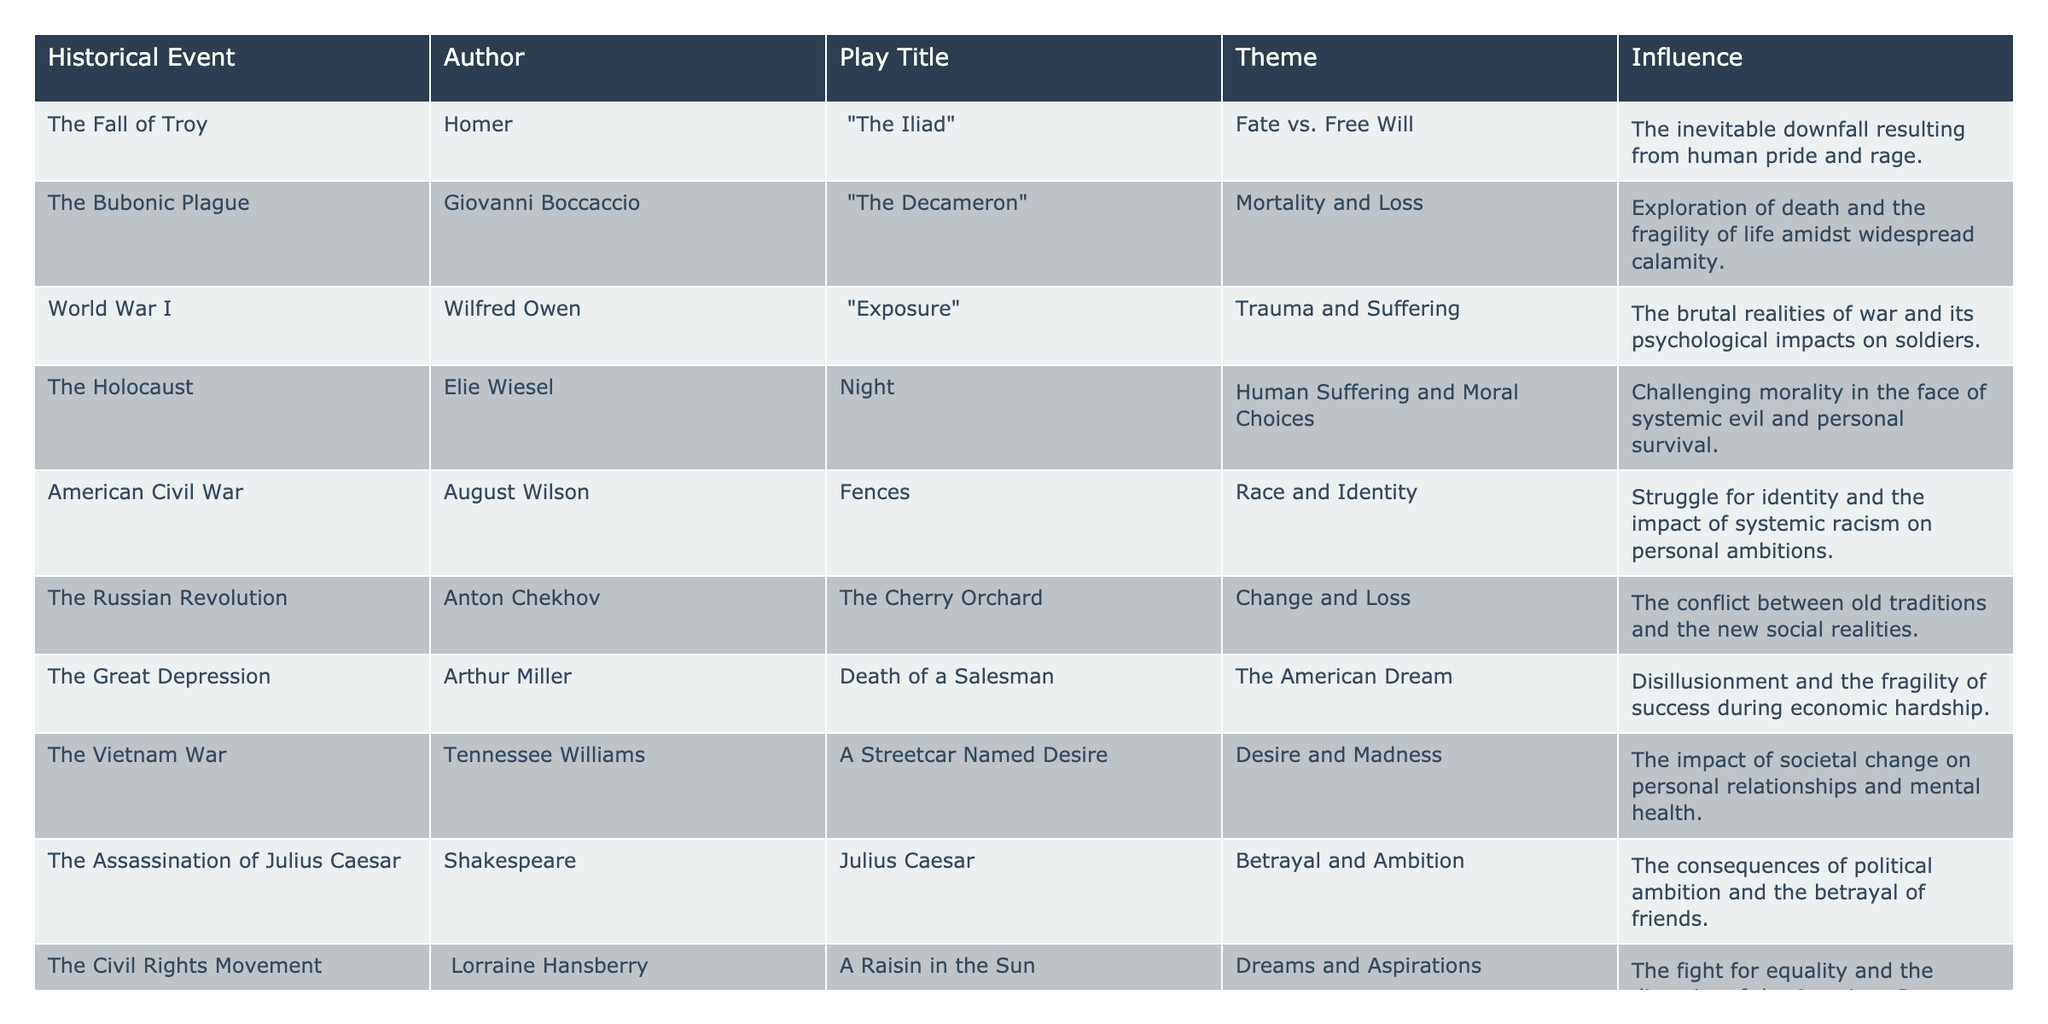What is the theme of "Death of a Salesman"? Referring to the table, under the play title "Death of a Salesman," the theme listed is "The American Dream."
Answer: The American Dream Which historical event influenced "A Raisin in the Sun"? In the table, "A Raisin in the Sun" is influenced by "The Civil Rights Movement."
Answer: The Civil Rights Movement Who wrote the play "The Iliad"? The play "The Iliad" is attributed to the author Homer, as mentioned in the table.
Answer: Homer What theme does "Exposure" explore? According to the table, "Exposure" explores the theme of "Trauma and Suffering."
Answer: Trauma and Suffering How many plays are influenced by wars? The table lists four plays associated with historical war events: "Exposure," "Night," "A Streetcar Named Desire," and "Julius Caesar."
Answer: Four Is "The Great Depression" associated with themes of success? Yes, the table shows that "Death of a Salesman," which is influenced by "The Great Depression," deals with themes of disillusionment and the fragility of success.
Answer: Yes Which play reflects the conflict between old traditions and new realities? The table indicates that "The Cherry Orchard" deals with the theme of change and loss, reflecting the conflict between old traditions and new social realities.
Answer: The Cherry Orchard How does the theme of "Fate vs. Free Will" in "The Iliad" relate to human emotions? "The Iliad" explores the human emotions of pride and rage leading to an inevitable downfall, which aligns with the theme of "Fate vs. Free Will" as described in the table.
Answer: It relates through pride and rage Among the plays listed, which one focuses on racial identity? According to the table, "Fences" by August Wilson focuses on the theme of race and identity.
Answer: Fences What is the common theme between "Night" and "A Streetcar Named Desire"? The commonality lies in both plays exploring human suffering; "Night" focuses on systemic evil, while "A Streetcar Named Desire" delves into personal relationships affected by societal changes.
Answer: Human suffering 